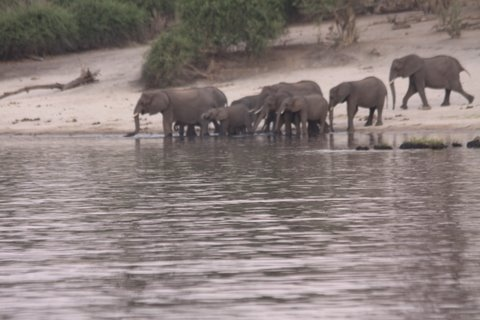Describe the objects in this image and their specific colors. I can see elephant in gray, darkgray, and black tones, elephant in gray, darkgray, and black tones, elephant in gray, darkgray, and black tones, elephant in gray and black tones, and elephant in gray and black tones in this image. 